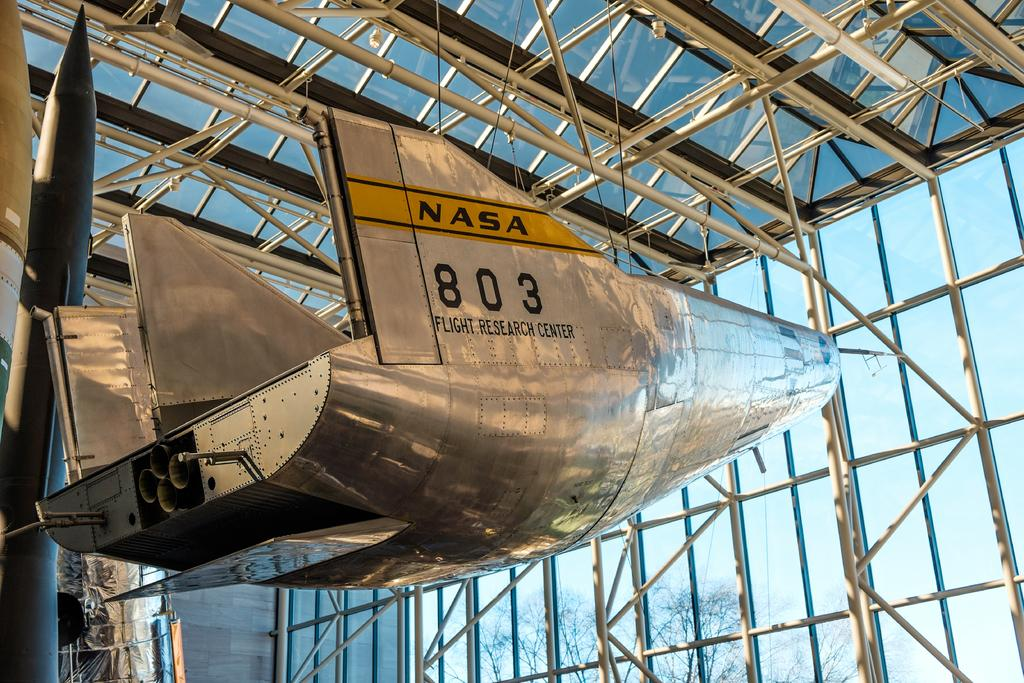What is the main subject of the image? The main subject of the image is a rocket. How is the rocket positioned in the image? The rocket is hanged from the top. What type of structure can be seen in the image? There are iron grills in the image. What type of natural element is present in the image? There are trees in the image. Can you tell me how many ants are crawling on the rocket in the image? There are no ants present in the image; it features a rocket hanging from the top with iron grills and trees in the background. 